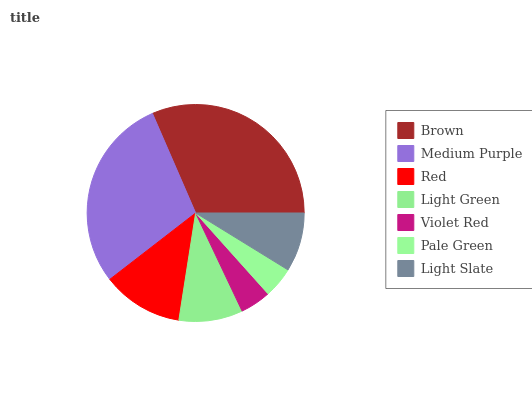Is Violet Red the minimum?
Answer yes or no. Yes. Is Brown the maximum?
Answer yes or no. Yes. Is Medium Purple the minimum?
Answer yes or no. No. Is Medium Purple the maximum?
Answer yes or no. No. Is Brown greater than Medium Purple?
Answer yes or no. Yes. Is Medium Purple less than Brown?
Answer yes or no. Yes. Is Medium Purple greater than Brown?
Answer yes or no. No. Is Brown less than Medium Purple?
Answer yes or no. No. Is Light Green the high median?
Answer yes or no. Yes. Is Light Green the low median?
Answer yes or no. Yes. Is Violet Red the high median?
Answer yes or no. No. Is Brown the low median?
Answer yes or no. No. 